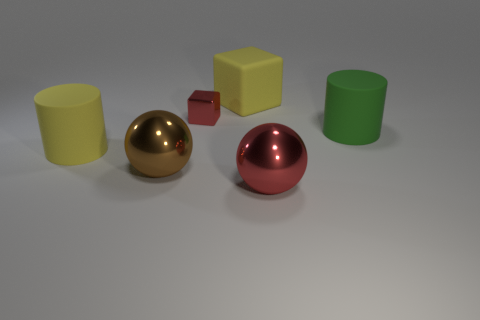What is the color of the metal thing that is right of the yellow matte thing on the right side of the yellow cylinder?
Keep it short and to the point. Red. What color is the small thing that is made of the same material as the big brown thing?
Your response must be concise. Red. What number of other small metallic objects are the same color as the tiny metal object?
Provide a short and direct response. 0. What number of things are either cylinders or yellow objects?
Make the answer very short. 3. There is a brown metallic object that is the same size as the green thing; what shape is it?
Give a very brief answer. Sphere. What number of objects are on the right side of the small object and behind the green matte thing?
Ensure brevity in your answer.  1. There is a cylinder behind the large yellow rubber cylinder; what material is it?
Provide a short and direct response. Rubber. There is a green object that is the same material as the yellow cylinder; what size is it?
Offer a terse response. Large. There is a red object in front of the big yellow rubber cylinder; is its size the same as the brown thing in front of the big green cylinder?
Make the answer very short. Yes. What is the material of the brown object that is the same size as the yellow rubber cylinder?
Provide a succinct answer. Metal. 